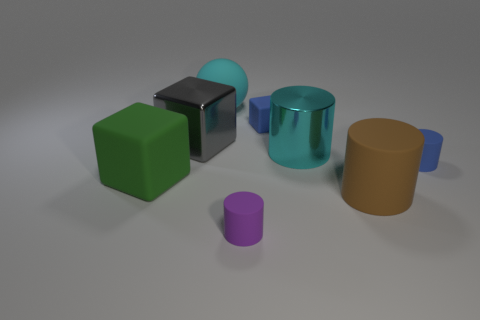Add 1 big spheres. How many objects exist? 9 Subtract all cubes. How many objects are left? 5 Add 8 green blocks. How many green blocks are left? 9 Add 5 big gray shiny things. How many big gray shiny things exist? 6 Subtract 1 blue cylinders. How many objects are left? 7 Subtract all brown rubber cylinders. Subtract all green cubes. How many objects are left? 6 